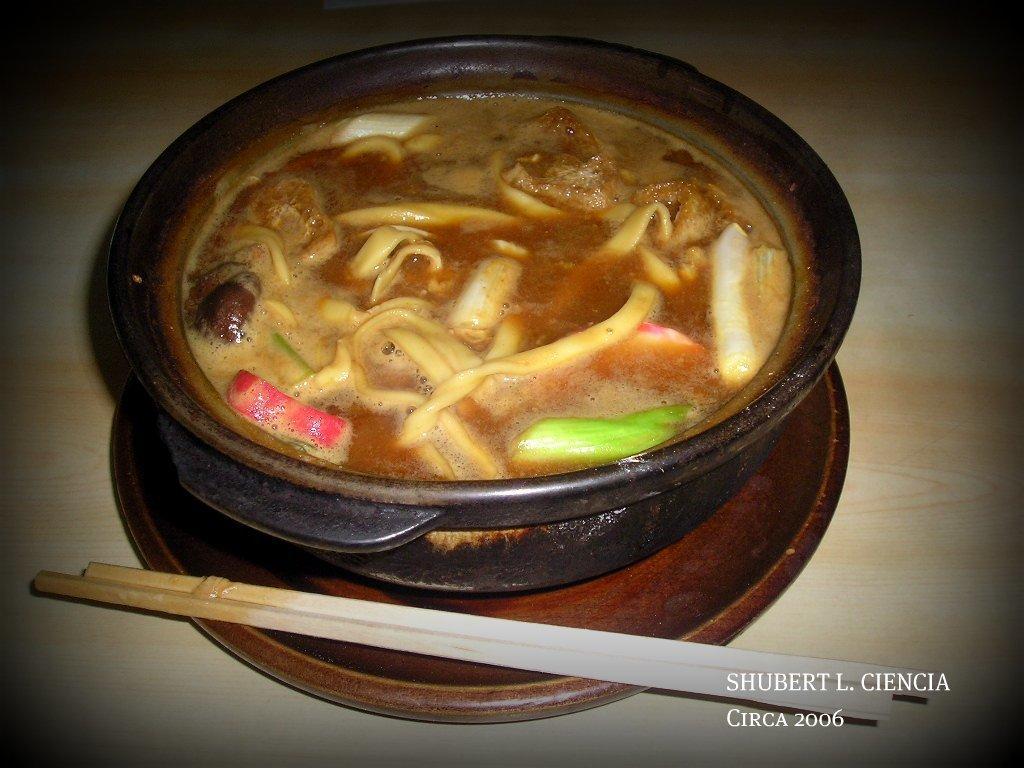Describe this image in one or two sentences. On this surface we can see a plate, bowl, chopsticks and food. Right side bottom of the image there is a watermark. 